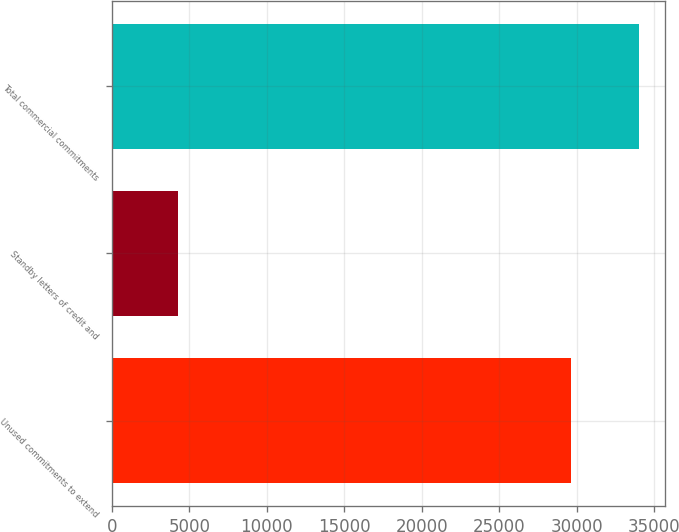Convert chart to OTSL. <chart><loc_0><loc_0><loc_500><loc_500><bar_chart><fcel>Unused commitments to extend<fcel>Standby letters of credit and<fcel>Total commercial commitments<nl><fcel>29612<fcel>4299<fcel>34019<nl></chart> 